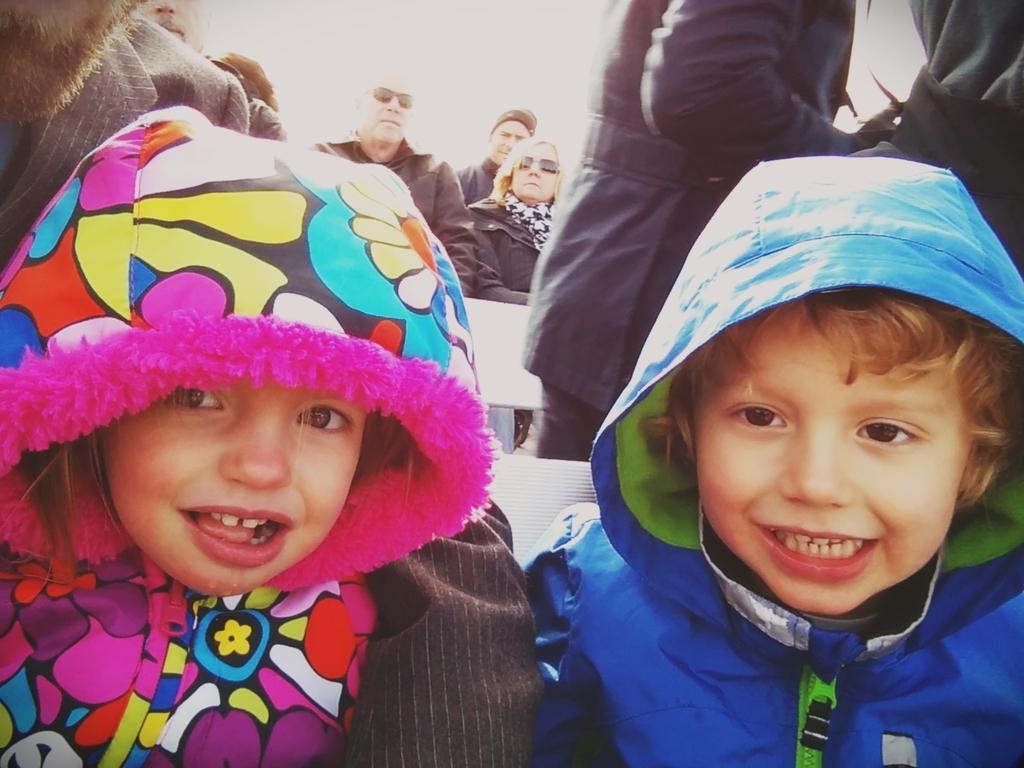Describe this image in one or two sentences. In this image there are two kids, there are persons sitting, there are persons truncated towards the right of the image, there are person truncated towards the left of the image, the background of the person is white in color. 